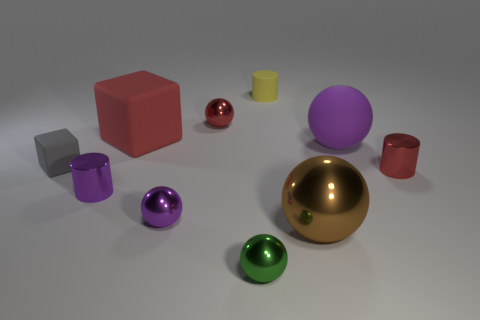Subtract all green spheres. How many spheres are left? 4 Subtract all tiny purple spheres. How many spheres are left? 4 Subtract all cyan balls. Subtract all purple cubes. How many balls are left? 5 Subtract all cylinders. How many objects are left? 7 Add 7 purple shiny balls. How many purple shiny balls are left? 8 Add 2 tiny purple balls. How many tiny purple balls exist? 3 Subtract 0 blue cubes. How many objects are left? 10 Subtract all tiny yellow rubber cylinders. Subtract all large purple rubber objects. How many objects are left? 8 